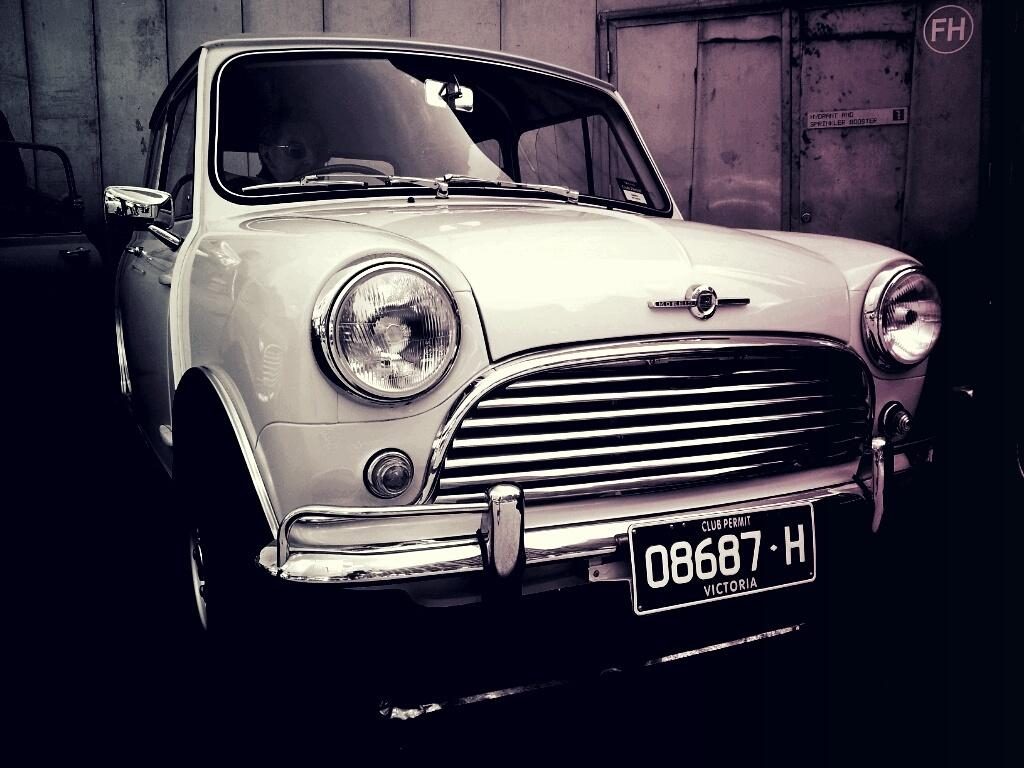<image>
Provide a brief description of the given image. A old car located inside a building has a Victoria Club Permit license plate on the front bumper. 